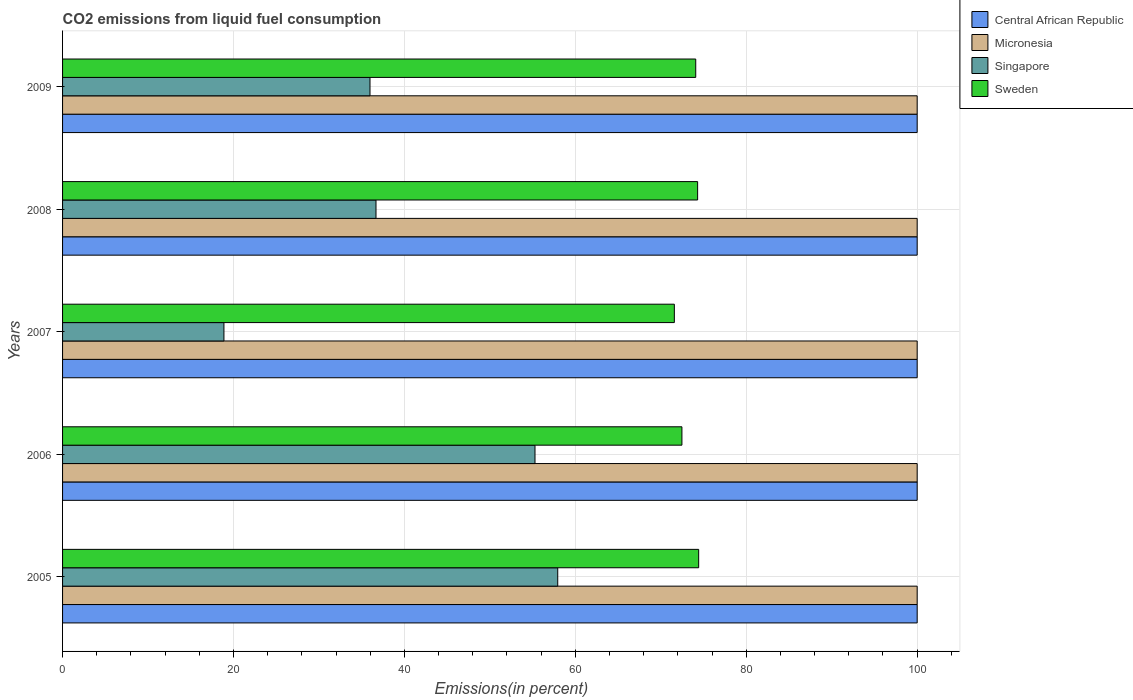How many different coloured bars are there?
Your answer should be compact. 4. How many groups of bars are there?
Provide a succinct answer. 5. Are the number of bars per tick equal to the number of legend labels?
Your answer should be compact. Yes. Are the number of bars on each tick of the Y-axis equal?
Make the answer very short. Yes. How many bars are there on the 1st tick from the bottom?
Offer a very short reply. 4. In how many cases, is the number of bars for a given year not equal to the number of legend labels?
Give a very brief answer. 0. What is the total CO2 emitted in Sweden in 2006?
Provide a succinct answer. 72.47. Across all years, what is the maximum total CO2 emitted in Central African Republic?
Provide a succinct answer. 100. Across all years, what is the minimum total CO2 emitted in Central African Republic?
Make the answer very short. 100. In which year was the total CO2 emitted in Central African Republic maximum?
Give a very brief answer. 2005. In which year was the total CO2 emitted in Singapore minimum?
Provide a succinct answer. 2007. What is the total total CO2 emitted in Micronesia in the graph?
Ensure brevity in your answer.  500. What is the difference between the total CO2 emitted in Micronesia in 2006 and that in 2007?
Provide a short and direct response. 0. What is the difference between the total CO2 emitted in Central African Republic in 2006 and the total CO2 emitted in Sweden in 2009?
Offer a terse response. 25.91. In the year 2008, what is the difference between the total CO2 emitted in Singapore and total CO2 emitted in Sweden?
Keep it short and to the point. -37.64. In how many years, is the total CO2 emitted in Singapore greater than 28 %?
Offer a terse response. 4. What is the ratio of the total CO2 emitted in Sweden in 2006 to that in 2009?
Provide a succinct answer. 0.98. Is the total CO2 emitted in Central African Republic in 2005 less than that in 2006?
Your response must be concise. No. Is the difference between the total CO2 emitted in Singapore in 2006 and 2008 greater than the difference between the total CO2 emitted in Sweden in 2006 and 2008?
Provide a short and direct response. Yes. What is the difference between the highest and the second highest total CO2 emitted in Sweden?
Provide a succinct answer. 0.12. What is the difference between the highest and the lowest total CO2 emitted in Central African Republic?
Your answer should be very brief. 0. In how many years, is the total CO2 emitted in Central African Republic greater than the average total CO2 emitted in Central African Republic taken over all years?
Provide a succinct answer. 0. Is the sum of the total CO2 emitted in Singapore in 2006 and 2008 greater than the maximum total CO2 emitted in Micronesia across all years?
Offer a very short reply. No. Is it the case that in every year, the sum of the total CO2 emitted in Micronesia and total CO2 emitted in Sweden is greater than the sum of total CO2 emitted in Singapore and total CO2 emitted in Central African Republic?
Your response must be concise. Yes. What does the 1st bar from the top in 2006 represents?
Offer a very short reply. Sweden. What does the 4th bar from the bottom in 2009 represents?
Give a very brief answer. Sweden. Is it the case that in every year, the sum of the total CO2 emitted in Singapore and total CO2 emitted in Micronesia is greater than the total CO2 emitted in Central African Republic?
Provide a short and direct response. Yes. How many years are there in the graph?
Your answer should be compact. 5. Are the values on the major ticks of X-axis written in scientific E-notation?
Your answer should be compact. No. Does the graph contain grids?
Make the answer very short. Yes. How many legend labels are there?
Your answer should be compact. 4. How are the legend labels stacked?
Provide a short and direct response. Vertical. What is the title of the graph?
Ensure brevity in your answer.  CO2 emissions from liquid fuel consumption. What is the label or title of the X-axis?
Provide a succinct answer. Emissions(in percent). What is the label or title of the Y-axis?
Your answer should be very brief. Years. What is the Emissions(in percent) in Micronesia in 2005?
Give a very brief answer. 100. What is the Emissions(in percent) in Singapore in 2005?
Provide a short and direct response. 57.94. What is the Emissions(in percent) of Sweden in 2005?
Keep it short and to the point. 74.43. What is the Emissions(in percent) in Central African Republic in 2006?
Ensure brevity in your answer.  100. What is the Emissions(in percent) in Singapore in 2006?
Offer a terse response. 55.28. What is the Emissions(in percent) of Sweden in 2006?
Ensure brevity in your answer.  72.47. What is the Emissions(in percent) in Singapore in 2007?
Make the answer very short. 18.88. What is the Emissions(in percent) in Sweden in 2007?
Make the answer very short. 71.59. What is the Emissions(in percent) of Central African Republic in 2008?
Your answer should be very brief. 100. What is the Emissions(in percent) in Micronesia in 2008?
Keep it short and to the point. 100. What is the Emissions(in percent) in Singapore in 2008?
Your answer should be very brief. 36.68. What is the Emissions(in percent) of Sweden in 2008?
Your response must be concise. 74.31. What is the Emissions(in percent) in Micronesia in 2009?
Keep it short and to the point. 100. What is the Emissions(in percent) of Singapore in 2009?
Make the answer very short. 35.97. What is the Emissions(in percent) of Sweden in 2009?
Your answer should be compact. 74.09. Across all years, what is the maximum Emissions(in percent) in Singapore?
Provide a succinct answer. 57.94. Across all years, what is the maximum Emissions(in percent) in Sweden?
Offer a terse response. 74.43. Across all years, what is the minimum Emissions(in percent) in Central African Republic?
Keep it short and to the point. 100. Across all years, what is the minimum Emissions(in percent) of Singapore?
Keep it short and to the point. 18.88. Across all years, what is the minimum Emissions(in percent) in Sweden?
Your answer should be compact. 71.59. What is the total Emissions(in percent) in Singapore in the graph?
Give a very brief answer. 204.76. What is the total Emissions(in percent) of Sweden in the graph?
Your answer should be compact. 366.89. What is the difference between the Emissions(in percent) of Micronesia in 2005 and that in 2006?
Ensure brevity in your answer.  0. What is the difference between the Emissions(in percent) in Singapore in 2005 and that in 2006?
Your answer should be very brief. 2.66. What is the difference between the Emissions(in percent) in Sweden in 2005 and that in 2006?
Your response must be concise. 1.96. What is the difference between the Emissions(in percent) of Singapore in 2005 and that in 2007?
Provide a succinct answer. 39.06. What is the difference between the Emissions(in percent) of Sweden in 2005 and that in 2007?
Offer a terse response. 2.85. What is the difference between the Emissions(in percent) in Micronesia in 2005 and that in 2008?
Give a very brief answer. 0. What is the difference between the Emissions(in percent) in Singapore in 2005 and that in 2008?
Provide a short and direct response. 21.27. What is the difference between the Emissions(in percent) in Sweden in 2005 and that in 2008?
Give a very brief answer. 0.12. What is the difference between the Emissions(in percent) of Micronesia in 2005 and that in 2009?
Your answer should be compact. 0. What is the difference between the Emissions(in percent) in Singapore in 2005 and that in 2009?
Provide a succinct answer. 21.97. What is the difference between the Emissions(in percent) of Sweden in 2005 and that in 2009?
Provide a short and direct response. 0.34. What is the difference between the Emissions(in percent) of Central African Republic in 2006 and that in 2007?
Your answer should be compact. 0. What is the difference between the Emissions(in percent) in Singapore in 2006 and that in 2007?
Offer a terse response. 36.4. What is the difference between the Emissions(in percent) of Sweden in 2006 and that in 2007?
Provide a short and direct response. 0.89. What is the difference between the Emissions(in percent) in Central African Republic in 2006 and that in 2008?
Provide a short and direct response. 0. What is the difference between the Emissions(in percent) of Micronesia in 2006 and that in 2008?
Provide a short and direct response. 0. What is the difference between the Emissions(in percent) in Singapore in 2006 and that in 2008?
Keep it short and to the point. 18.61. What is the difference between the Emissions(in percent) in Sweden in 2006 and that in 2008?
Your answer should be very brief. -1.84. What is the difference between the Emissions(in percent) of Central African Republic in 2006 and that in 2009?
Provide a succinct answer. 0. What is the difference between the Emissions(in percent) of Singapore in 2006 and that in 2009?
Provide a succinct answer. 19.31. What is the difference between the Emissions(in percent) in Sweden in 2006 and that in 2009?
Offer a terse response. -1.61. What is the difference between the Emissions(in percent) of Micronesia in 2007 and that in 2008?
Make the answer very short. 0. What is the difference between the Emissions(in percent) of Singapore in 2007 and that in 2008?
Offer a terse response. -17.79. What is the difference between the Emissions(in percent) in Sweden in 2007 and that in 2008?
Make the answer very short. -2.73. What is the difference between the Emissions(in percent) in Singapore in 2007 and that in 2009?
Provide a short and direct response. -17.09. What is the difference between the Emissions(in percent) of Sweden in 2007 and that in 2009?
Provide a short and direct response. -2.5. What is the difference between the Emissions(in percent) in Micronesia in 2008 and that in 2009?
Your answer should be very brief. 0. What is the difference between the Emissions(in percent) of Singapore in 2008 and that in 2009?
Keep it short and to the point. 0.7. What is the difference between the Emissions(in percent) in Sweden in 2008 and that in 2009?
Ensure brevity in your answer.  0.22. What is the difference between the Emissions(in percent) of Central African Republic in 2005 and the Emissions(in percent) of Micronesia in 2006?
Your response must be concise. 0. What is the difference between the Emissions(in percent) of Central African Republic in 2005 and the Emissions(in percent) of Singapore in 2006?
Your answer should be very brief. 44.72. What is the difference between the Emissions(in percent) of Central African Republic in 2005 and the Emissions(in percent) of Sweden in 2006?
Keep it short and to the point. 27.53. What is the difference between the Emissions(in percent) in Micronesia in 2005 and the Emissions(in percent) in Singapore in 2006?
Provide a succinct answer. 44.72. What is the difference between the Emissions(in percent) in Micronesia in 2005 and the Emissions(in percent) in Sweden in 2006?
Provide a succinct answer. 27.53. What is the difference between the Emissions(in percent) of Singapore in 2005 and the Emissions(in percent) of Sweden in 2006?
Offer a terse response. -14.53. What is the difference between the Emissions(in percent) in Central African Republic in 2005 and the Emissions(in percent) in Singapore in 2007?
Offer a terse response. 81.12. What is the difference between the Emissions(in percent) in Central African Republic in 2005 and the Emissions(in percent) in Sweden in 2007?
Your answer should be compact. 28.41. What is the difference between the Emissions(in percent) of Micronesia in 2005 and the Emissions(in percent) of Singapore in 2007?
Keep it short and to the point. 81.12. What is the difference between the Emissions(in percent) in Micronesia in 2005 and the Emissions(in percent) in Sweden in 2007?
Provide a short and direct response. 28.41. What is the difference between the Emissions(in percent) in Singapore in 2005 and the Emissions(in percent) in Sweden in 2007?
Give a very brief answer. -13.64. What is the difference between the Emissions(in percent) in Central African Republic in 2005 and the Emissions(in percent) in Singapore in 2008?
Give a very brief answer. 63.32. What is the difference between the Emissions(in percent) in Central African Republic in 2005 and the Emissions(in percent) in Sweden in 2008?
Make the answer very short. 25.69. What is the difference between the Emissions(in percent) of Micronesia in 2005 and the Emissions(in percent) of Singapore in 2008?
Your answer should be compact. 63.32. What is the difference between the Emissions(in percent) in Micronesia in 2005 and the Emissions(in percent) in Sweden in 2008?
Ensure brevity in your answer.  25.69. What is the difference between the Emissions(in percent) in Singapore in 2005 and the Emissions(in percent) in Sweden in 2008?
Make the answer very short. -16.37. What is the difference between the Emissions(in percent) in Central African Republic in 2005 and the Emissions(in percent) in Singapore in 2009?
Make the answer very short. 64.03. What is the difference between the Emissions(in percent) of Central African Republic in 2005 and the Emissions(in percent) of Sweden in 2009?
Provide a succinct answer. 25.91. What is the difference between the Emissions(in percent) of Micronesia in 2005 and the Emissions(in percent) of Singapore in 2009?
Keep it short and to the point. 64.03. What is the difference between the Emissions(in percent) in Micronesia in 2005 and the Emissions(in percent) in Sweden in 2009?
Give a very brief answer. 25.91. What is the difference between the Emissions(in percent) of Singapore in 2005 and the Emissions(in percent) of Sweden in 2009?
Ensure brevity in your answer.  -16.15. What is the difference between the Emissions(in percent) in Central African Republic in 2006 and the Emissions(in percent) in Micronesia in 2007?
Your answer should be compact. 0. What is the difference between the Emissions(in percent) in Central African Republic in 2006 and the Emissions(in percent) in Singapore in 2007?
Your answer should be compact. 81.12. What is the difference between the Emissions(in percent) in Central African Republic in 2006 and the Emissions(in percent) in Sweden in 2007?
Provide a short and direct response. 28.41. What is the difference between the Emissions(in percent) in Micronesia in 2006 and the Emissions(in percent) in Singapore in 2007?
Keep it short and to the point. 81.12. What is the difference between the Emissions(in percent) of Micronesia in 2006 and the Emissions(in percent) of Sweden in 2007?
Provide a succinct answer. 28.41. What is the difference between the Emissions(in percent) in Singapore in 2006 and the Emissions(in percent) in Sweden in 2007?
Keep it short and to the point. -16.31. What is the difference between the Emissions(in percent) in Central African Republic in 2006 and the Emissions(in percent) in Singapore in 2008?
Give a very brief answer. 63.32. What is the difference between the Emissions(in percent) in Central African Republic in 2006 and the Emissions(in percent) in Sweden in 2008?
Make the answer very short. 25.69. What is the difference between the Emissions(in percent) in Micronesia in 2006 and the Emissions(in percent) in Singapore in 2008?
Your answer should be very brief. 63.32. What is the difference between the Emissions(in percent) in Micronesia in 2006 and the Emissions(in percent) in Sweden in 2008?
Keep it short and to the point. 25.69. What is the difference between the Emissions(in percent) in Singapore in 2006 and the Emissions(in percent) in Sweden in 2008?
Your answer should be compact. -19.03. What is the difference between the Emissions(in percent) of Central African Republic in 2006 and the Emissions(in percent) of Micronesia in 2009?
Your response must be concise. 0. What is the difference between the Emissions(in percent) of Central African Republic in 2006 and the Emissions(in percent) of Singapore in 2009?
Make the answer very short. 64.03. What is the difference between the Emissions(in percent) of Central African Republic in 2006 and the Emissions(in percent) of Sweden in 2009?
Ensure brevity in your answer.  25.91. What is the difference between the Emissions(in percent) in Micronesia in 2006 and the Emissions(in percent) in Singapore in 2009?
Make the answer very short. 64.03. What is the difference between the Emissions(in percent) in Micronesia in 2006 and the Emissions(in percent) in Sweden in 2009?
Your answer should be very brief. 25.91. What is the difference between the Emissions(in percent) in Singapore in 2006 and the Emissions(in percent) in Sweden in 2009?
Ensure brevity in your answer.  -18.81. What is the difference between the Emissions(in percent) of Central African Republic in 2007 and the Emissions(in percent) of Micronesia in 2008?
Your answer should be compact. 0. What is the difference between the Emissions(in percent) of Central African Republic in 2007 and the Emissions(in percent) of Singapore in 2008?
Make the answer very short. 63.32. What is the difference between the Emissions(in percent) in Central African Republic in 2007 and the Emissions(in percent) in Sweden in 2008?
Provide a short and direct response. 25.69. What is the difference between the Emissions(in percent) in Micronesia in 2007 and the Emissions(in percent) in Singapore in 2008?
Your response must be concise. 63.32. What is the difference between the Emissions(in percent) in Micronesia in 2007 and the Emissions(in percent) in Sweden in 2008?
Your response must be concise. 25.69. What is the difference between the Emissions(in percent) of Singapore in 2007 and the Emissions(in percent) of Sweden in 2008?
Provide a succinct answer. -55.43. What is the difference between the Emissions(in percent) in Central African Republic in 2007 and the Emissions(in percent) in Singapore in 2009?
Ensure brevity in your answer.  64.03. What is the difference between the Emissions(in percent) in Central African Republic in 2007 and the Emissions(in percent) in Sweden in 2009?
Give a very brief answer. 25.91. What is the difference between the Emissions(in percent) of Micronesia in 2007 and the Emissions(in percent) of Singapore in 2009?
Your answer should be compact. 64.03. What is the difference between the Emissions(in percent) in Micronesia in 2007 and the Emissions(in percent) in Sweden in 2009?
Your answer should be very brief. 25.91. What is the difference between the Emissions(in percent) in Singapore in 2007 and the Emissions(in percent) in Sweden in 2009?
Make the answer very short. -55.2. What is the difference between the Emissions(in percent) of Central African Republic in 2008 and the Emissions(in percent) of Micronesia in 2009?
Offer a terse response. 0. What is the difference between the Emissions(in percent) in Central African Republic in 2008 and the Emissions(in percent) in Singapore in 2009?
Ensure brevity in your answer.  64.03. What is the difference between the Emissions(in percent) in Central African Republic in 2008 and the Emissions(in percent) in Sweden in 2009?
Provide a succinct answer. 25.91. What is the difference between the Emissions(in percent) in Micronesia in 2008 and the Emissions(in percent) in Singapore in 2009?
Your response must be concise. 64.03. What is the difference between the Emissions(in percent) of Micronesia in 2008 and the Emissions(in percent) of Sweden in 2009?
Make the answer very short. 25.91. What is the difference between the Emissions(in percent) in Singapore in 2008 and the Emissions(in percent) in Sweden in 2009?
Offer a very short reply. -37.41. What is the average Emissions(in percent) in Central African Republic per year?
Provide a succinct answer. 100. What is the average Emissions(in percent) of Micronesia per year?
Provide a succinct answer. 100. What is the average Emissions(in percent) in Singapore per year?
Make the answer very short. 40.95. What is the average Emissions(in percent) of Sweden per year?
Your answer should be compact. 73.38. In the year 2005, what is the difference between the Emissions(in percent) in Central African Republic and Emissions(in percent) in Micronesia?
Offer a very short reply. 0. In the year 2005, what is the difference between the Emissions(in percent) in Central African Republic and Emissions(in percent) in Singapore?
Give a very brief answer. 42.06. In the year 2005, what is the difference between the Emissions(in percent) of Central African Republic and Emissions(in percent) of Sweden?
Your answer should be compact. 25.57. In the year 2005, what is the difference between the Emissions(in percent) of Micronesia and Emissions(in percent) of Singapore?
Offer a very short reply. 42.06. In the year 2005, what is the difference between the Emissions(in percent) of Micronesia and Emissions(in percent) of Sweden?
Your response must be concise. 25.57. In the year 2005, what is the difference between the Emissions(in percent) in Singapore and Emissions(in percent) in Sweden?
Offer a terse response. -16.49. In the year 2006, what is the difference between the Emissions(in percent) in Central African Republic and Emissions(in percent) in Micronesia?
Provide a short and direct response. 0. In the year 2006, what is the difference between the Emissions(in percent) in Central African Republic and Emissions(in percent) in Singapore?
Ensure brevity in your answer.  44.72. In the year 2006, what is the difference between the Emissions(in percent) of Central African Republic and Emissions(in percent) of Sweden?
Provide a succinct answer. 27.53. In the year 2006, what is the difference between the Emissions(in percent) of Micronesia and Emissions(in percent) of Singapore?
Offer a very short reply. 44.72. In the year 2006, what is the difference between the Emissions(in percent) in Micronesia and Emissions(in percent) in Sweden?
Your answer should be compact. 27.53. In the year 2006, what is the difference between the Emissions(in percent) of Singapore and Emissions(in percent) of Sweden?
Offer a terse response. -17.19. In the year 2007, what is the difference between the Emissions(in percent) of Central African Republic and Emissions(in percent) of Micronesia?
Offer a very short reply. 0. In the year 2007, what is the difference between the Emissions(in percent) of Central African Republic and Emissions(in percent) of Singapore?
Your answer should be compact. 81.12. In the year 2007, what is the difference between the Emissions(in percent) in Central African Republic and Emissions(in percent) in Sweden?
Ensure brevity in your answer.  28.41. In the year 2007, what is the difference between the Emissions(in percent) of Micronesia and Emissions(in percent) of Singapore?
Keep it short and to the point. 81.12. In the year 2007, what is the difference between the Emissions(in percent) in Micronesia and Emissions(in percent) in Sweden?
Provide a short and direct response. 28.41. In the year 2007, what is the difference between the Emissions(in percent) in Singapore and Emissions(in percent) in Sweden?
Offer a terse response. -52.7. In the year 2008, what is the difference between the Emissions(in percent) of Central African Republic and Emissions(in percent) of Singapore?
Give a very brief answer. 63.32. In the year 2008, what is the difference between the Emissions(in percent) in Central African Republic and Emissions(in percent) in Sweden?
Your response must be concise. 25.69. In the year 2008, what is the difference between the Emissions(in percent) of Micronesia and Emissions(in percent) of Singapore?
Give a very brief answer. 63.32. In the year 2008, what is the difference between the Emissions(in percent) in Micronesia and Emissions(in percent) in Sweden?
Provide a short and direct response. 25.69. In the year 2008, what is the difference between the Emissions(in percent) of Singapore and Emissions(in percent) of Sweden?
Ensure brevity in your answer.  -37.64. In the year 2009, what is the difference between the Emissions(in percent) in Central African Republic and Emissions(in percent) in Singapore?
Give a very brief answer. 64.03. In the year 2009, what is the difference between the Emissions(in percent) in Central African Republic and Emissions(in percent) in Sweden?
Ensure brevity in your answer.  25.91. In the year 2009, what is the difference between the Emissions(in percent) of Micronesia and Emissions(in percent) of Singapore?
Your answer should be compact. 64.03. In the year 2009, what is the difference between the Emissions(in percent) of Micronesia and Emissions(in percent) of Sweden?
Offer a terse response. 25.91. In the year 2009, what is the difference between the Emissions(in percent) of Singapore and Emissions(in percent) of Sweden?
Your answer should be compact. -38.11. What is the ratio of the Emissions(in percent) in Micronesia in 2005 to that in 2006?
Your response must be concise. 1. What is the ratio of the Emissions(in percent) in Singapore in 2005 to that in 2006?
Provide a short and direct response. 1.05. What is the ratio of the Emissions(in percent) in Sweden in 2005 to that in 2006?
Your response must be concise. 1.03. What is the ratio of the Emissions(in percent) of Micronesia in 2005 to that in 2007?
Your answer should be compact. 1. What is the ratio of the Emissions(in percent) in Singapore in 2005 to that in 2007?
Keep it short and to the point. 3.07. What is the ratio of the Emissions(in percent) in Sweden in 2005 to that in 2007?
Your response must be concise. 1.04. What is the ratio of the Emissions(in percent) of Singapore in 2005 to that in 2008?
Offer a very short reply. 1.58. What is the ratio of the Emissions(in percent) in Sweden in 2005 to that in 2008?
Keep it short and to the point. 1. What is the ratio of the Emissions(in percent) in Micronesia in 2005 to that in 2009?
Provide a succinct answer. 1. What is the ratio of the Emissions(in percent) of Singapore in 2005 to that in 2009?
Make the answer very short. 1.61. What is the ratio of the Emissions(in percent) in Singapore in 2006 to that in 2007?
Your answer should be very brief. 2.93. What is the ratio of the Emissions(in percent) of Sweden in 2006 to that in 2007?
Provide a succinct answer. 1.01. What is the ratio of the Emissions(in percent) of Central African Republic in 2006 to that in 2008?
Ensure brevity in your answer.  1. What is the ratio of the Emissions(in percent) in Singapore in 2006 to that in 2008?
Give a very brief answer. 1.51. What is the ratio of the Emissions(in percent) in Sweden in 2006 to that in 2008?
Your response must be concise. 0.98. What is the ratio of the Emissions(in percent) of Central African Republic in 2006 to that in 2009?
Provide a short and direct response. 1. What is the ratio of the Emissions(in percent) of Singapore in 2006 to that in 2009?
Ensure brevity in your answer.  1.54. What is the ratio of the Emissions(in percent) in Sweden in 2006 to that in 2009?
Give a very brief answer. 0.98. What is the ratio of the Emissions(in percent) in Central African Republic in 2007 to that in 2008?
Give a very brief answer. 1. What is the ratio of the Emissions(in percent) of Micronesia in 2007 to that in 2008?
Make the answer very short. 1. What is the ratio of the Emissions(in percent) of Singapore in 2007 to that in 2008?
Your answer should be compact. 0.51. What is the ratio of the Emissions(in percent) in Sweden in 2007 to that in 2008?
Give a very brief answer. 0.96. What is the ratio of the Emissions(in percent) of Central African Republic in 2007 to that in 2009?
Provide a succinct answer. 1. What is the ratio of the Emissions(in percent) in Singapore in 2007 to that in 2009?
Ensure brevity in your answer.  0.52. What is the ratio of the Emissions(in percent) in Sweden in 2007 to that in 2009?
Provide a succinct answer. 0.97. What is the ratio of the Emissions(in percent) of Micronesia in 2008 to that in 2009?
Provide a short and direct response. 1. What is the ratio of the Emissions(in percent) in Singapore in 2008 to that in 2009?
Give a very brief answer. 1.02. What is the difference between the highest and the second highest Emissions(in percent) of Central African Republic?
Your answer should be compact. 0. What is the difference between the highest and the second highest Emissions(in percent) in Singapore?
Offer a terse response. 2.66. What is the difference between the highest and the second highest Emissions(in percent) of Sweden?
Keep it short and to the point. 0.12. What is the difference between the highest and the lowest Emissions(in percent) of Singapore?
Provide a succinct answer. 39.06. What is the difference between the highest and the lowest Emissions(in percent) in Sweden?
Provide a succinct answer. 2.85. 